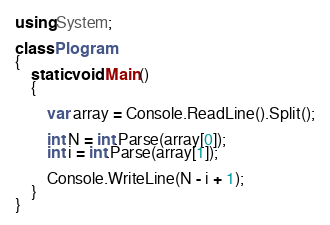Convert code to text. <code><loc_0><loc_0><loc_500><loc_500><_C#_>using System;

class Plogram
{
    static void Main()
    {

        var array = Console.ReadLine().Split();

        int N = int.Parse(array[0]);
        int i = int.Parse(array[1]);

        Console.WriteLine(N - i + 1);
    }
}</code> 